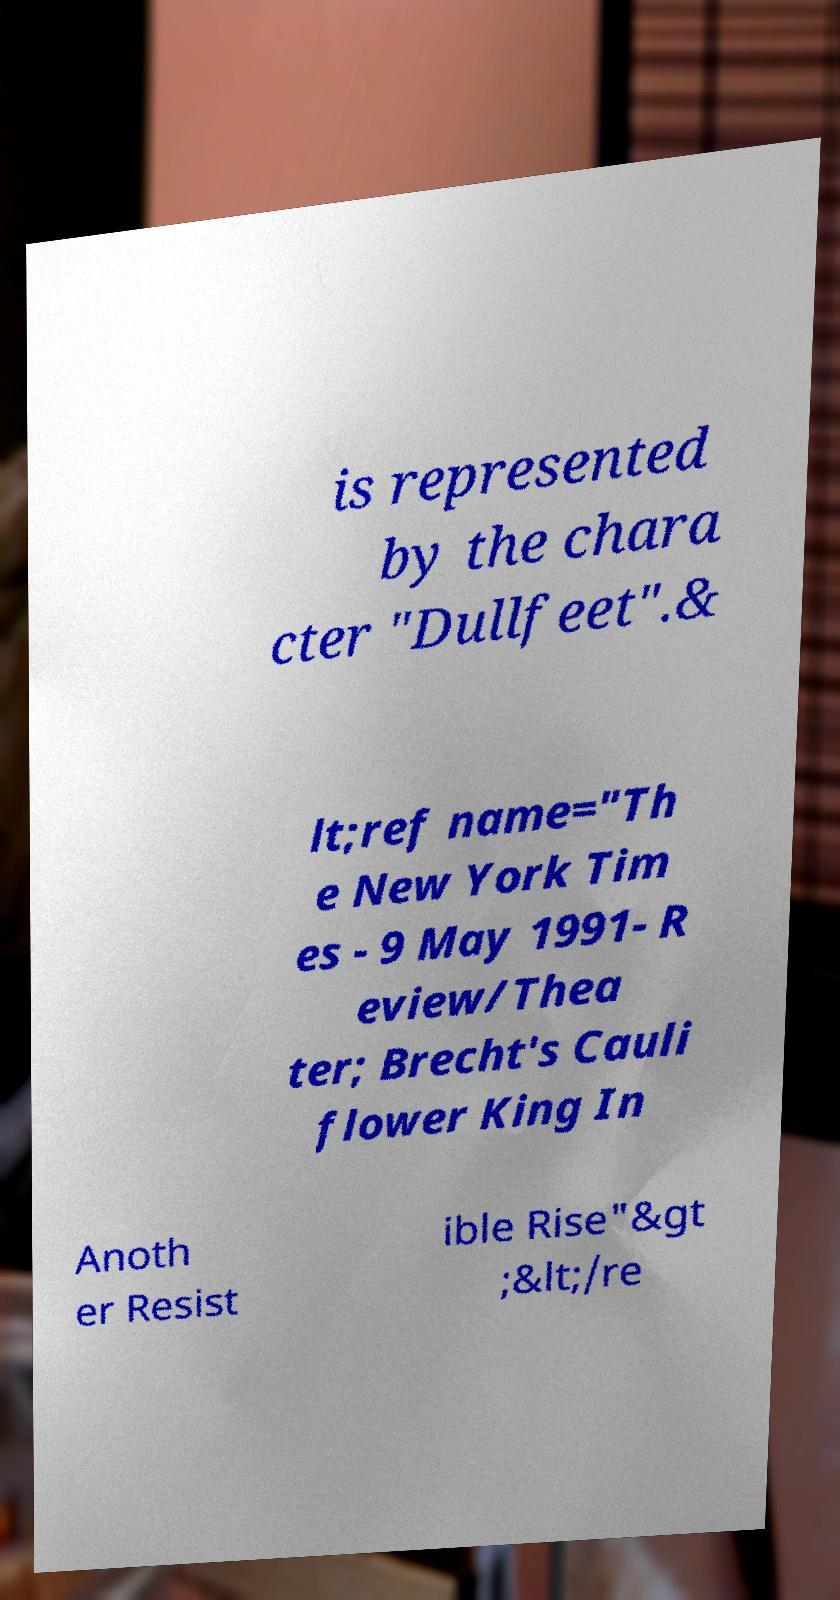Please read and relay the text visible in this image. What does it say? is represented by the chara cter "Dullfeet".& lt;ref name="Th e New York Tim es - 9 May 1991- R eview/Thea ter; Brecht's Cauli flower King In Anoth er Resist ible Rise"&gt ;&lt;/re 